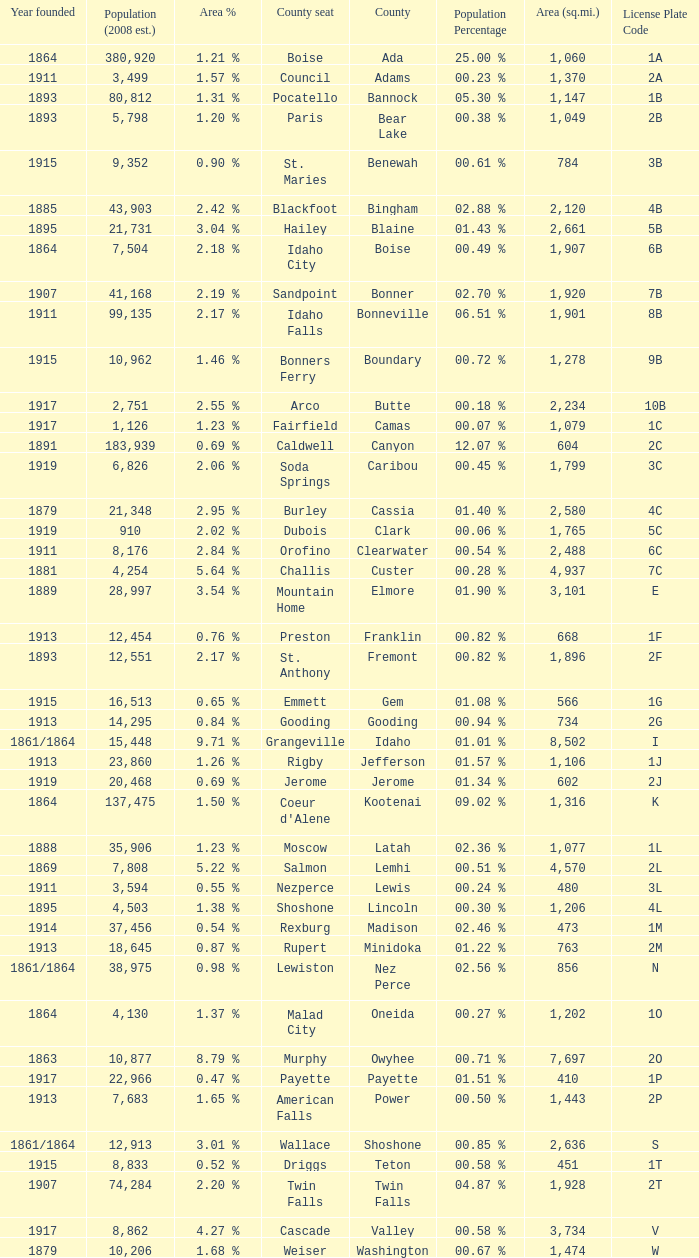What is the country seat for the license plate code 5c? Dubois. 